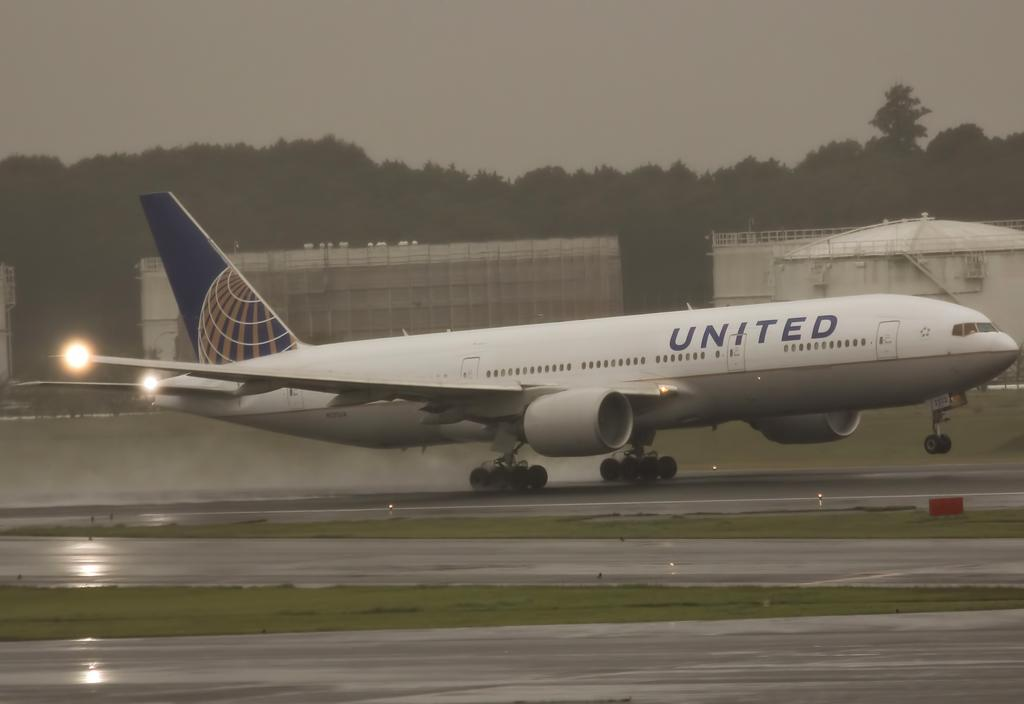What can be seen in the foreground of the picture? There are runways and grass in the foreground of the picture. What is happening on the runway? There is an airplane moving on the runway. What can be seen in the background of the picture? There are buildings, trees, and the sky visible in the background of the picture. What type of note is being distributed by the trees in the background of the image? There is no note being distributed by the trees in the background of the image. How is the sponge being used in the image? There is no sponge present in the image. 